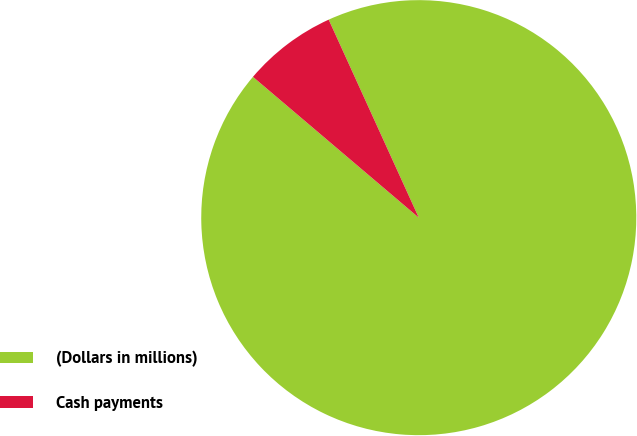Convert chart. <chart><loc_0><loc_0><loc_500><loc_500><pie_chart><fcel>(Dollars in millions)<fcel>Cash payments<nl><fcel>93.0%<fcel>7.0%<nl></chart> 